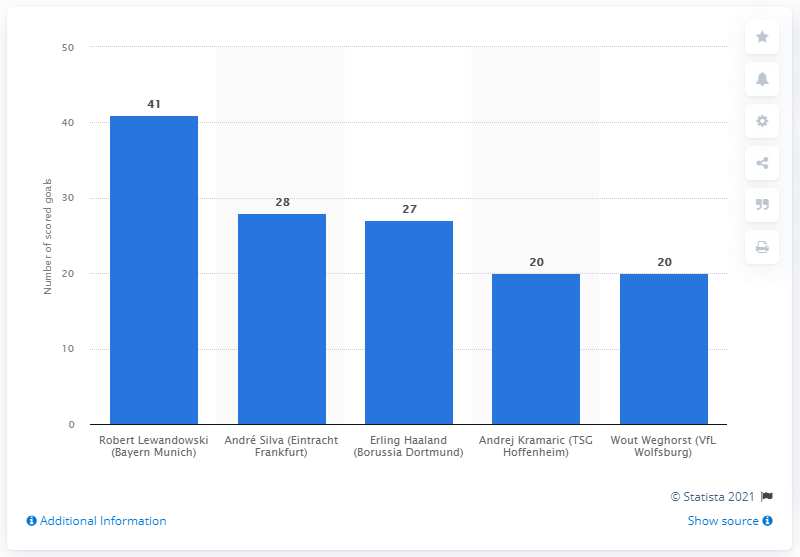Draw attention to some important aspects in this diagram. Robert Lewandowski scored 41 goals. Andr Silva scored 28 goals. 